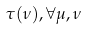Convert formula to latex. <formula><loc_0><loc_0><loc_500><loc_500>\tau ( \nu ) , \forall \mu , \nu</formula> 